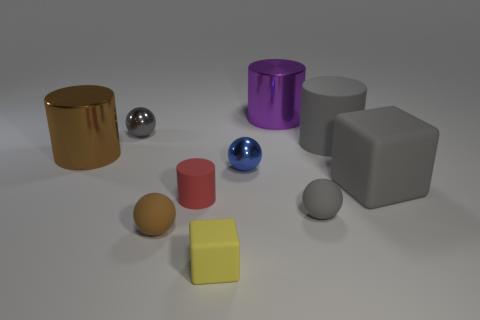There is a gray block; is its size the same as the metal ball left of the small brown rubber sphere?
Your answer should be very brief. No. What is the shape of the rubber thing left of the red cylinder?
Keep it short and to the point. Sphere. Is there a small matte sphere on the right side of the matte cylinder on the right side of the gray sphere that is to the right of the small blue shiny object?
Provide a short and direct response. No. There is a large gray object that is the same shape as the brown metal object; what is it made of?
Offer a terse response. Rubber. What number of blocks are either brown rubber things or tiny red objects?
Provide a succinct answer. 0. There is a cube that is to the right of the big gray rubber cylinder; is it the same size as the metal thing in front of the big brown metallic thing?
Provide a short and direct response. No. There is a brown thing that is behind the small rubber ball that is left of the yellow rubber cube; what is it made of?
Keep it short and to the point. Metal. Are there fewer brown matte spheres on the right side of the small rubber cube than big matte things?
Offer a very short reply. Yes. The small gray thing that is made of the same material as the small yellow cube is what shape?
Provide a short and direct response. Sphere. What number of other objects are the same shape as the purple object?
Provide a succinct answer. 3. 